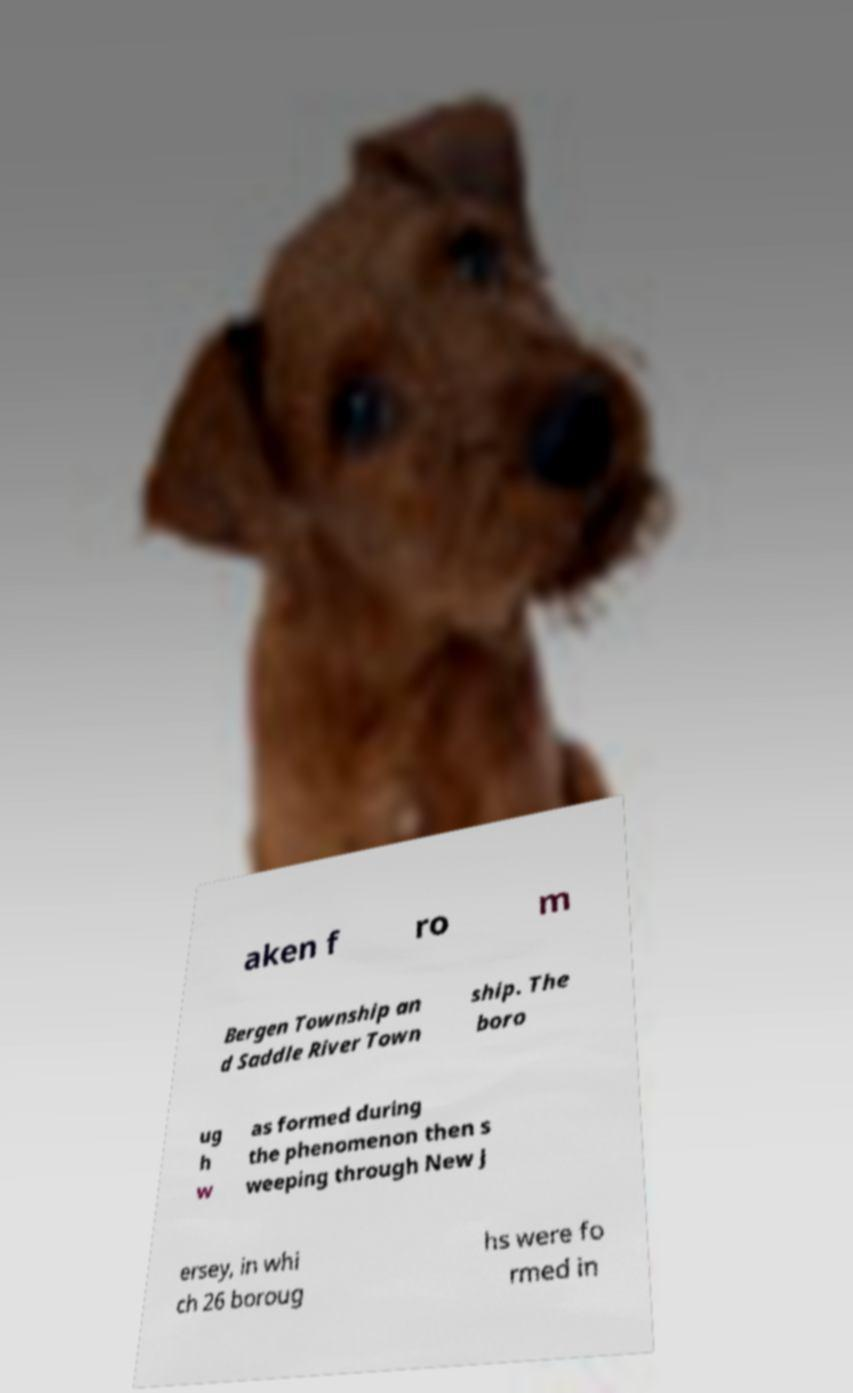What messages or text are displayed in this image? I need them in a readable, typed format. aken f ro m Bergen Township an d Saddle River Town ship. The boro ug h w as formed during the phenomenon then s weeping through New J ersey, in whi ch 26 boroug hs were fo rmed in 